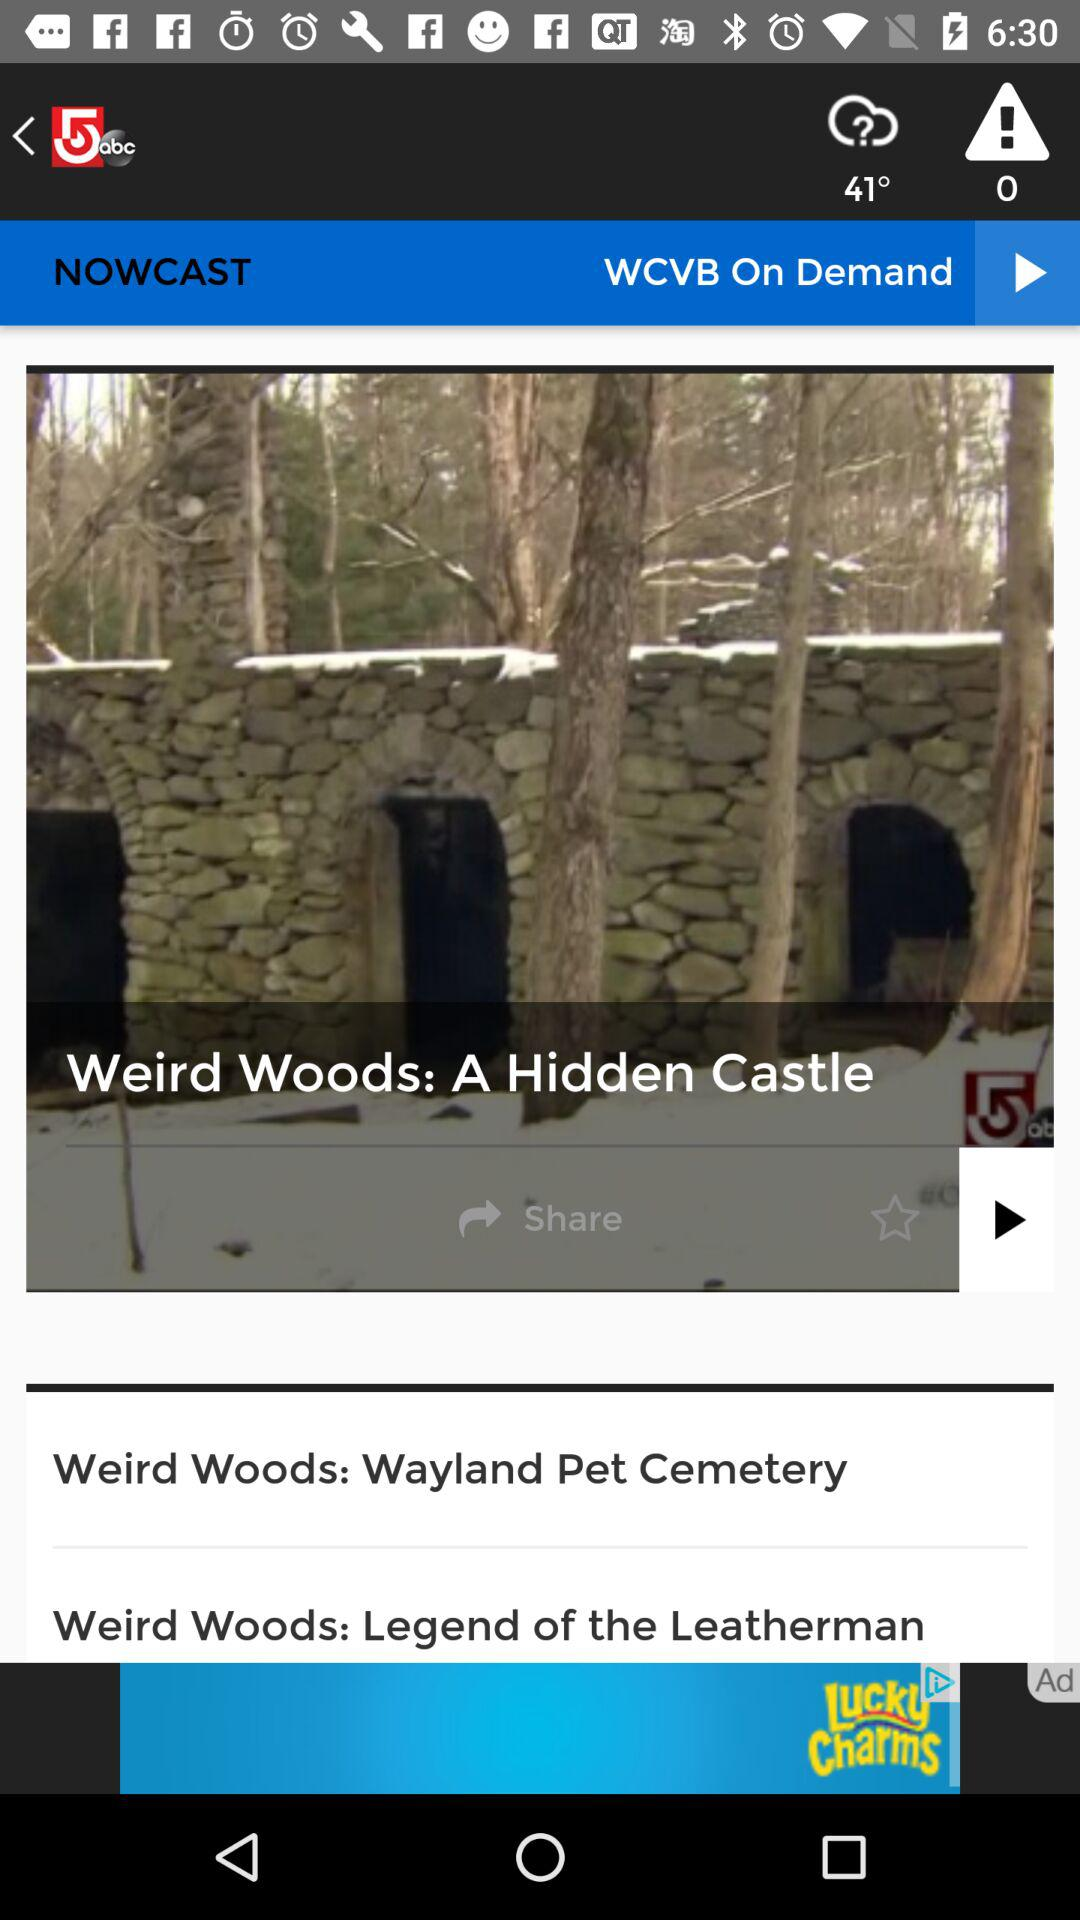What is the name of the application? The name of the application is "5abc". 